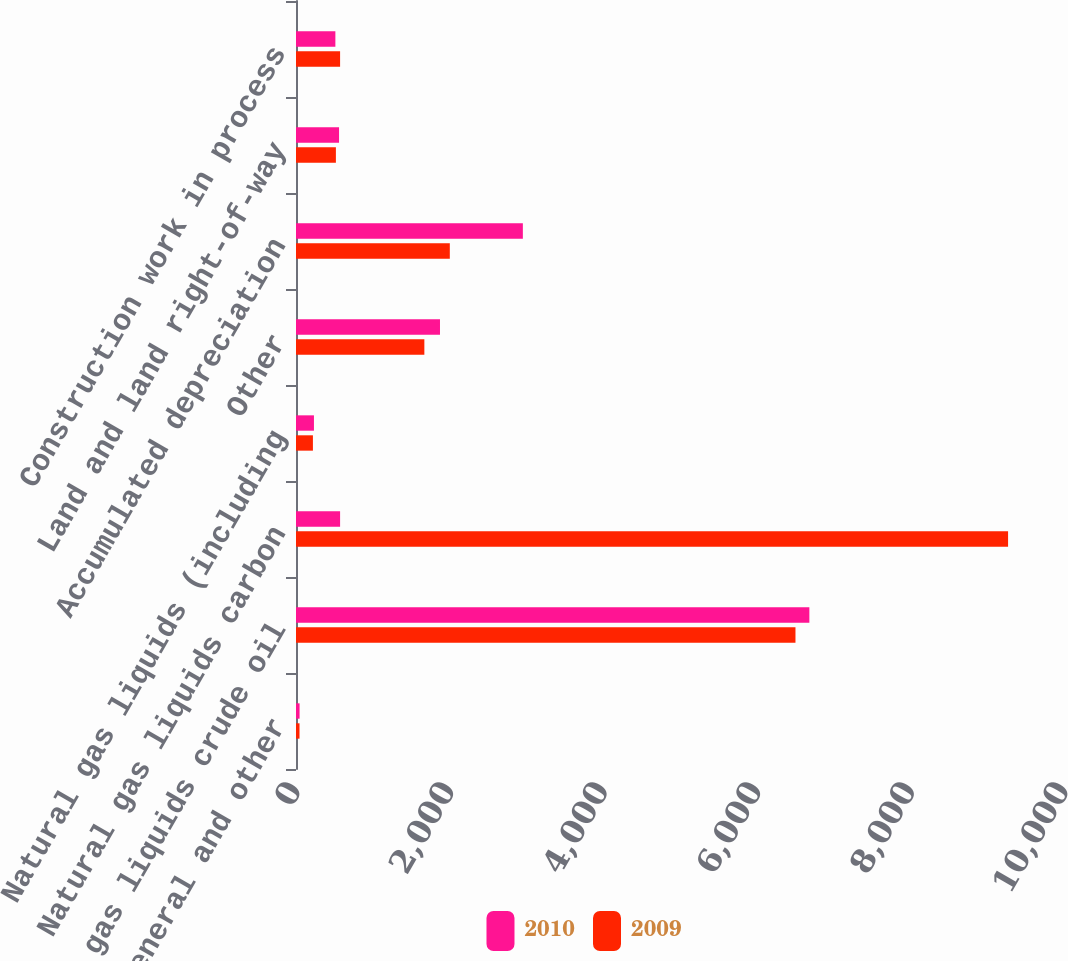Convert chart to OTSL. <chart><loc_0><loc_0><loc_500><loc_500><stacked_bar_chart><ecel><fcel>General and other<fcel>Natural gas liquids crude oil<fcel>Natural gas liquids carbon<fcel>Natural gas liquids (including<fcel>Other<fcel>Accumulated depreciation<fcel>Land and land right-of-way<fcel>Construction work in process<nl><fcel>2010<fcel>46.5<fcel>6684.4<fcel>574.1<fcel>233.7<fcel>1874.8<fcel>2953.9<fcel>560.5<fcel>512.7<nl><fcel>2009<fcel>45.7<fcel>6503.6<fcel>9271.8<fcel>220.3<fcel>1671.3<fcel>2002.8<fcel>519.5<fcel>574.1<nl></chart> 